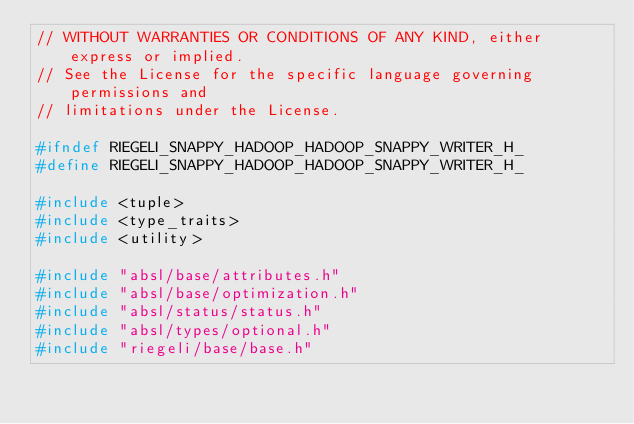<code> <loc_0><loc_0><loc_500><loc_500><_C_>// WITHOUT WARRANTIES OR CONDITIONS OF ANY KIND, either express or implied.
// See the License for the specific language governing permissions and
// limitations under the License.

#ifndef RIEGELI_SNAPPY_HADOOP_HADOOP_SNAPPY_WRITER_H_
#define RIEGELI_SNAPPY_HADOOP_HADOOP_SNAPPY_WRITER_H_

#include <tuple>
#include <type_traits>
#include <utility>

#include "absl/base/attributes.h"
#include "absl/base/optimization.h"
#include "absl/status/status.h"
#include "absl/types/optional.h"
#include "riegeli/base/base.h"</code> 